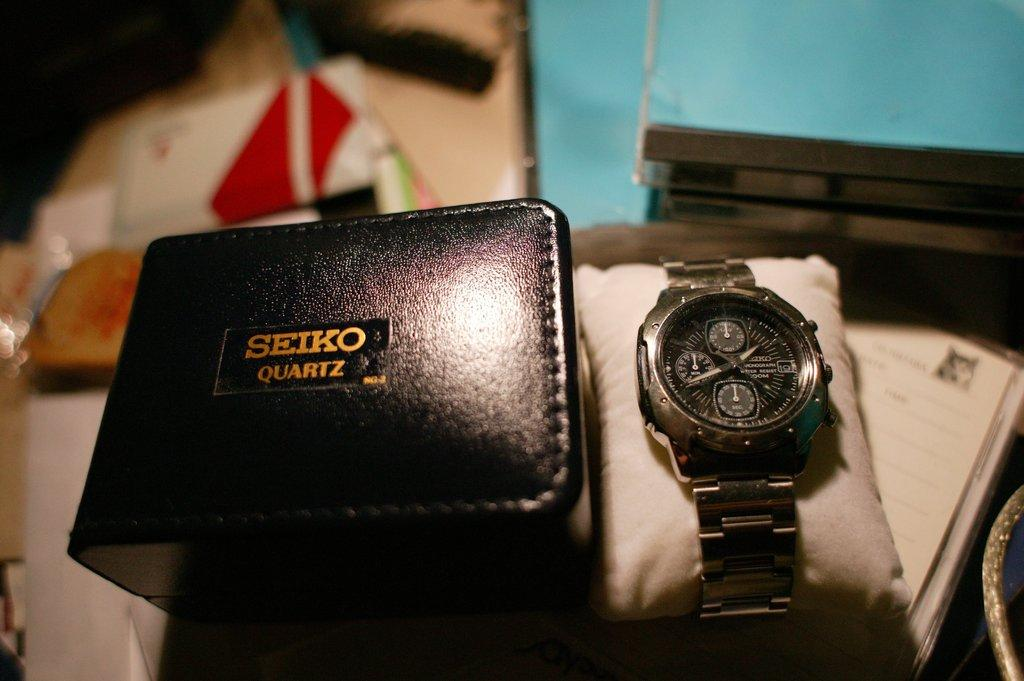<image>
Describe the image concisely. A silver watch is to the right of a Seiko Quartz black box. 